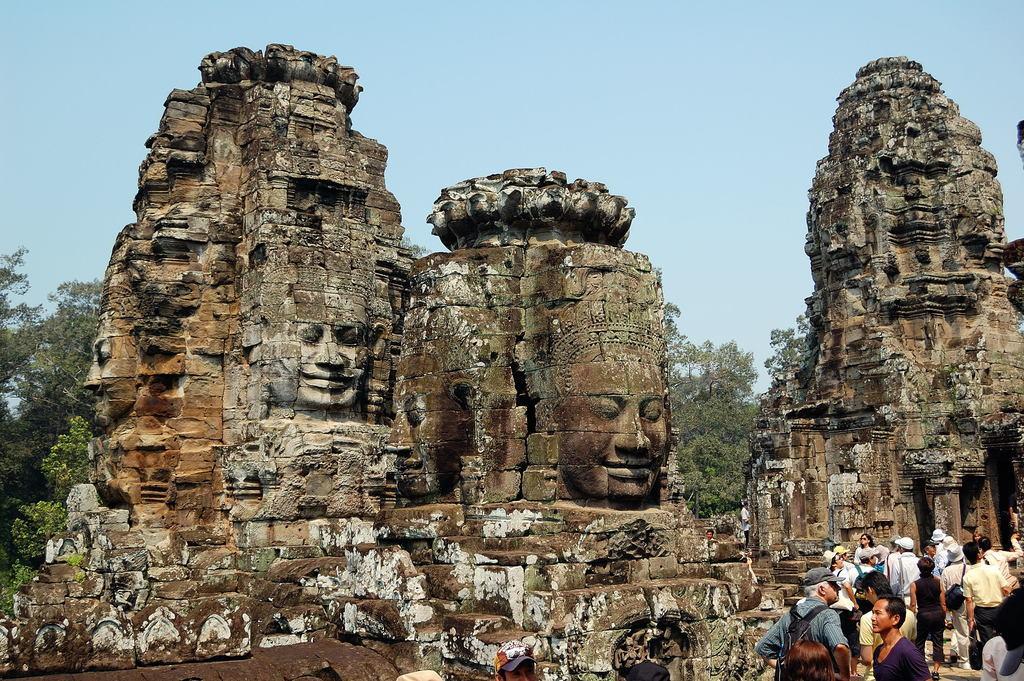How would you summarize this image in a sentence or two? In this picture we can see group of people, few people wore caps, in the background we can find few temples and trees. 